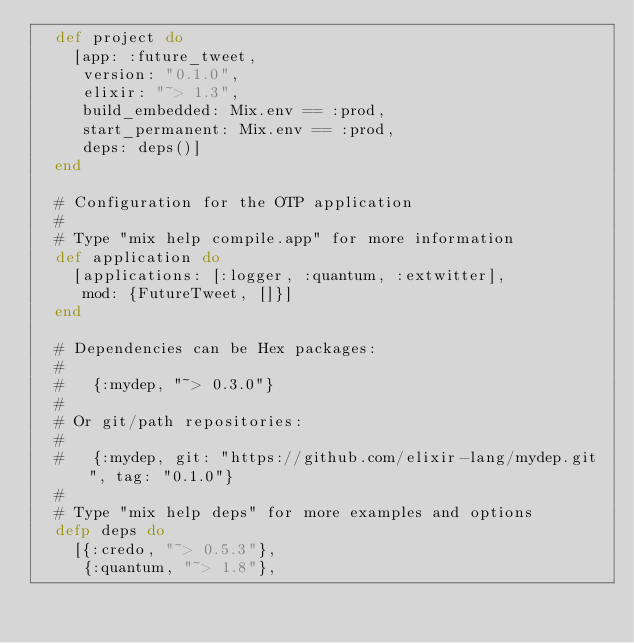<code> <loc_0><loc_0><loc_500><loc_500><_Elixir_>  def project do
    [app: :future_tweet,
     version: "0.1.0",
     elixir: "~> 1.3",
     build_embedded: Mix.env == :prod,
     start_permanent: Mix.env == :prod,
     deps: deps()]
  end

  # Configuration for the OTP application
  #
  # Type "mix help compile.app" for more information
  def application do
    [applications: [:logger, :quantum, :extwitter],
     mod: {FutureTweet, []}]
  end

  # Dependencies can be Hex packages:
  #
  #   {:mydep, "~> 0.3.0"}
  #
  # Or git/path repositories:
  #
  #   {:mydep, git: "https://github.com/elixir-lang/mydep.git", tag: "0.1.0"}
  #
  # Type "mix help deps" for more examples and options
  defp deps do
    [{:credo, "~> 0.5.3"},
     {:quantum, "~> 1.8"},</code> 